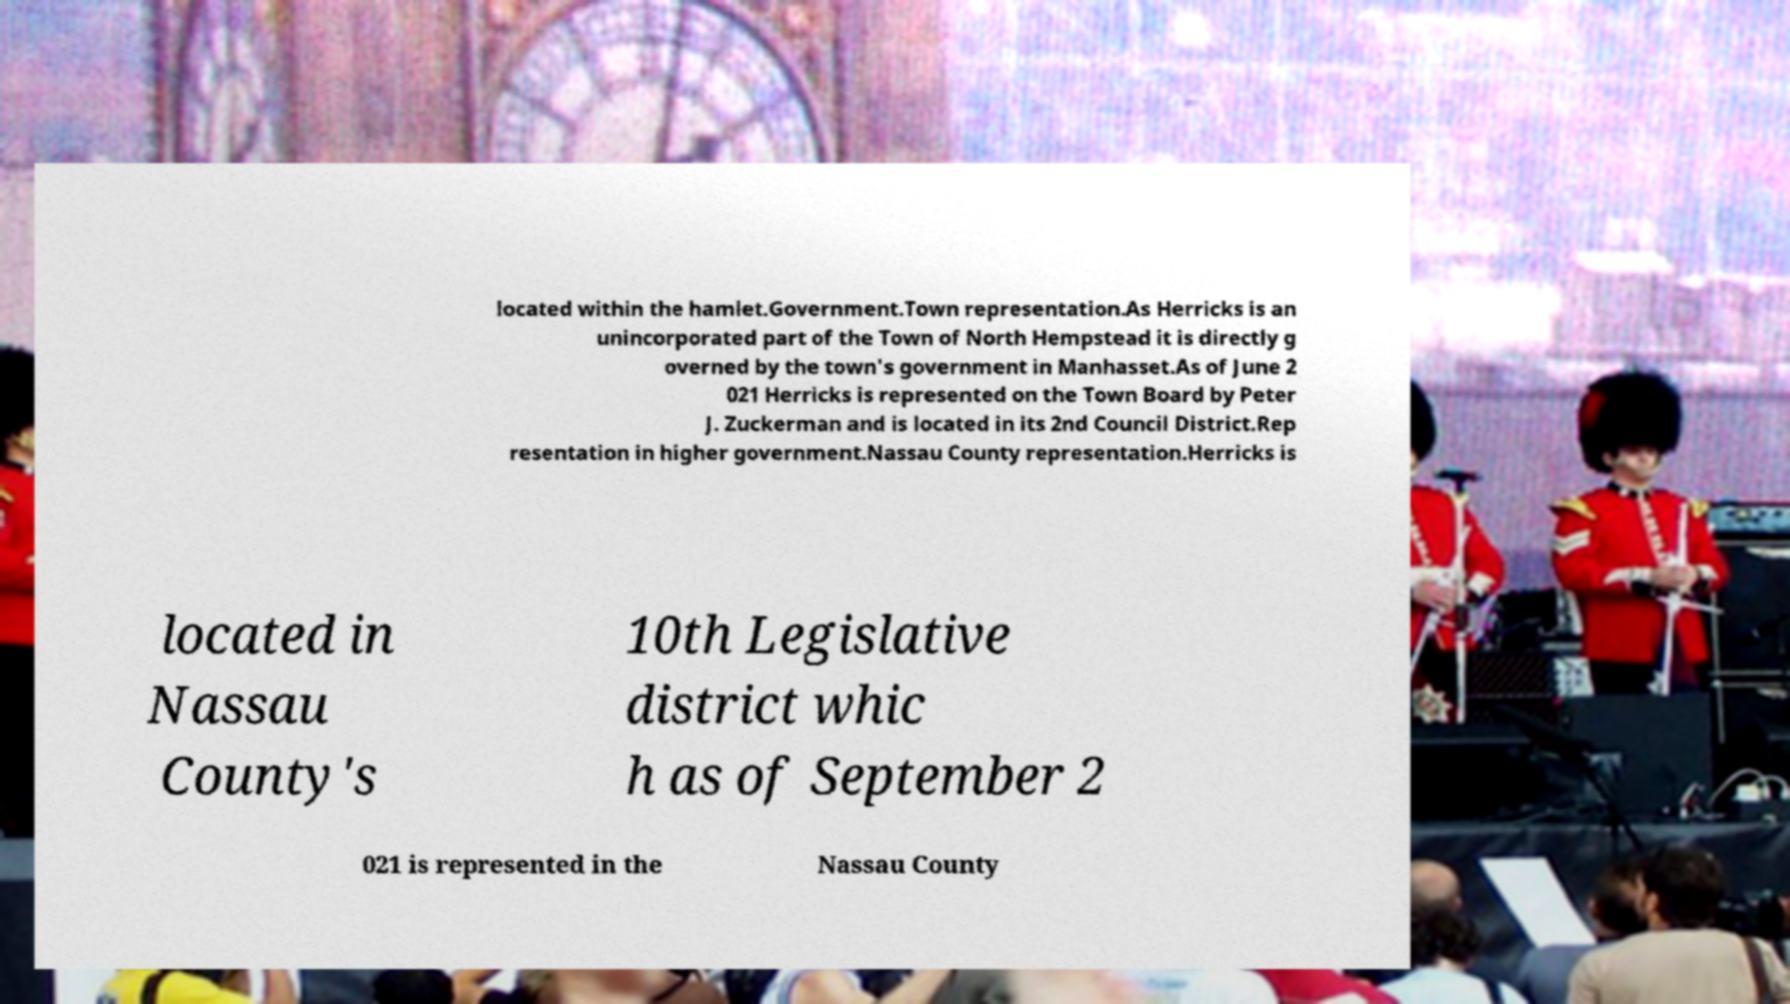What messages or text are displayed in this image? I need them in a readable, typed format. located within the hamlet.Government.Town representation.As Herricks is an unincorporated part of the Town of North Hempstead it is directly g overned by the town's government in Manhasset.As of June 2 021 Herricks is represented on the Town Board by Peter J. Zuckerman and is located in its 2nd Council District.Rep resentation in higher government.Nassau County representation.Herricks is located in Nassau County's 10th Legislative district whic h as of September 2 021 is represented in the Nassau County 